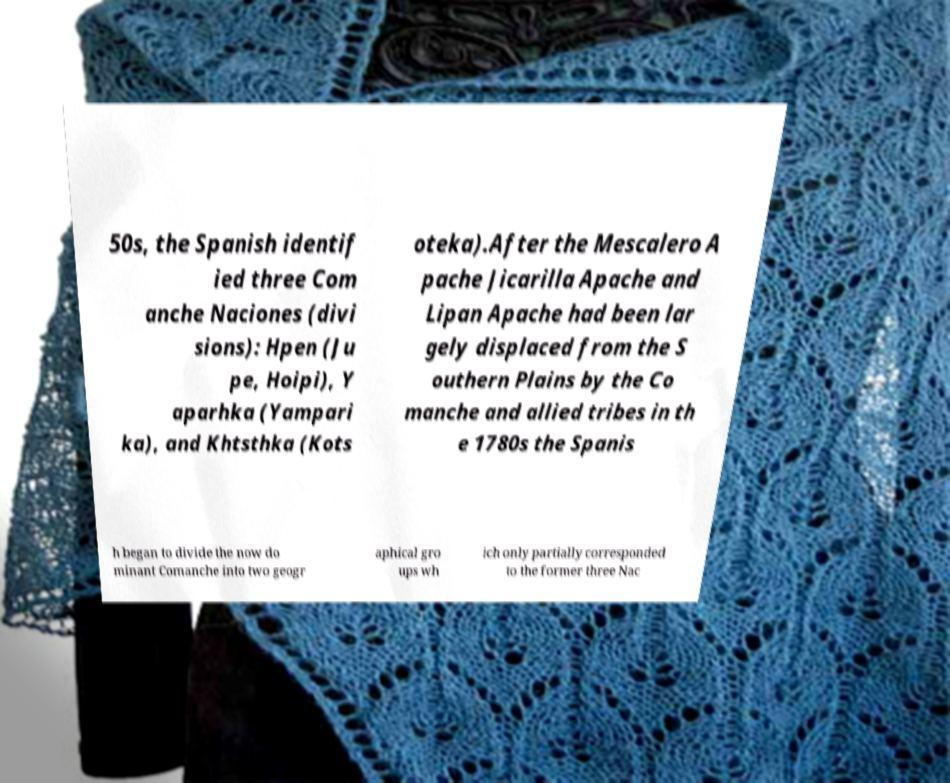Could you extract and type out the text from this image? 50s, the Spanish identif ied three Com anche Naciones (divi sions): Hpen (Ju pe, Hoipi), Y aparhka (Yampari ka), and Khtsthka (Kots oteka).After the Mescalero A pache Jicarilla Apache and Lipan Apache had been lar gely displaced from the S outhern Plains by the Co manche and allied tribes in th e 1780s the Spanis h began to divide the now do minant Comanche into two geogr aphical gro ups wh ich only partially corresponded to the former three Nac 